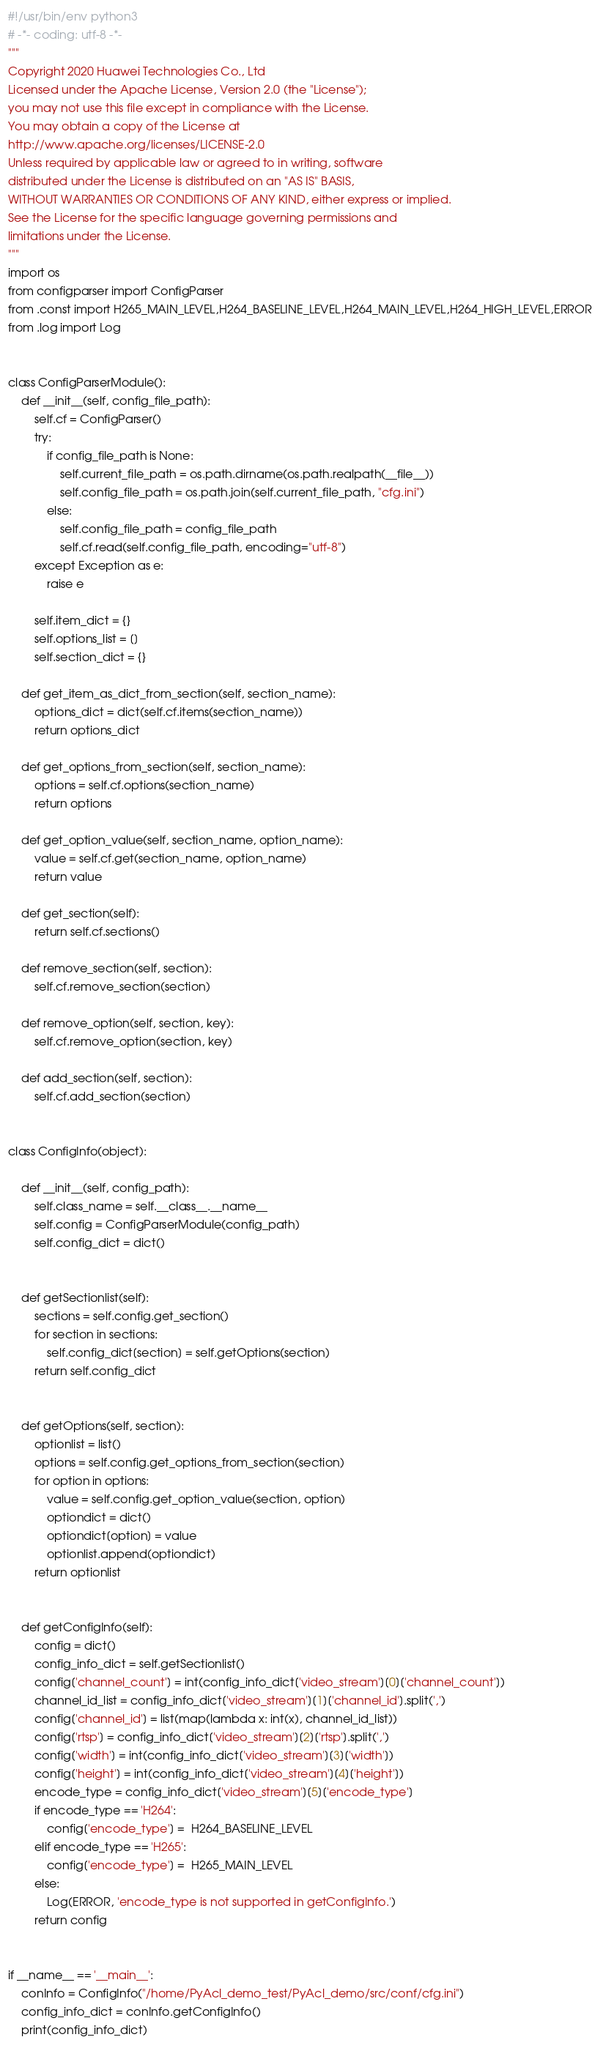<code> <loc_0><loc_0><loc_500><loc_500><_Python_>#!/usr/bin/env python3
# -*- coding: utf-8 -*-
"""
Copyright 2020 Huawei Technologies Co., Ltd
Licensed under the Apache License, Version 2.0 (the "License");
you may not use this file except in compliance with the License.
You may obtain a copy of the License at
http://www.apache.org/licenses/LICENSE-2.0
Unless required by applicable law or agreed to in writing, software
distributed under the License is distributed on an "AS IS" BASIS,
WITHOUT WARRANTIES OR CONDITIONS OF ANY KIND, either express or implied.
See the License for the specific language governing permissions and
limitations under the License.
"""
import os
from configparser import ConfigParser
from .const import H265_MAIN_LEVEL,H264_BASELINE_LEVEL,H264_MAIN_LEVEL,H264_HIGH_LEVEL,ERROR 
from .log import Log


class ConfigParserModule():
    def __init__(self, config_file_path):
        self.cf = ConfigParser()
        try:
            if config_file_path is None:
                self.current_file_path = os.path.dirname(os.path.realpath(__file__))
                self.config_file_path = os.path.join(self.current_file_path, "cfg.ini")
            else:
                self.config_file_path = config_file_path
                self.cf.read(self.config_file_path, encoding="utf-8")
        except Exception as e:
            raise e

        self.item_dict = {}
        self.options_list = []
        self.section_dict = {}

    def get_item_as_dict_from_section(self, section_name):
        options_dict = dict(self.cf.items(section_name))
        return options_dict

    def get_options_from_section(self, section_name):
        options = self.cf.options(section_name)
        return options

    def get_option_value(self, section_name, option_name):
        value = self.cf.get(section_name, option_name)
        return value

    def get_section(self):
        return self.cf.sections()

    def remove_section(self, section):
        self.cf.remove_section(section)

    def remove_option(self, section, key):
        self.cf.remove_option(section, key)

    def add_section(self, section):
        self.cf.add_section(section)


class ConfigInfo(object):
    
    def __init__(self, config_path):
        self.class_name = self.__class__.__name__
        self.config = ConfigParserModule(config_path)
        self.config_dict = dict()


    def getSectionlist(self):
        sections = self.config.get_section()
        for section in sections:
            self.config_dict[section] = self.getOptions(section)
        return self.config_dict


    def getOptions(self, section):
        optionlist = list()
        options = self.config.get_options_from_section(section)
        for option in options:
            value = self.config.get_option_value(section, option)
            optiondict = dict()
            optiondict[option] = value
            optionlist.append(optiondict)
        return optionlist


    def getConfigInfo(self):
        config = dict()
        config_info_dict = self.getSectionlist()
        config['channel_count'] = int(config_info_dict['video_stream'][0]['channel_count'])
        channel_id_list = config_info_dict['video_stream'][1]['channel_id'].split(',')
        config['channel_id'] = list(map(lambda x: int(x), channel_id_list))
        config['rtsp'] = config_info_dict['video_stream'][2]['rtsp'].split(',')
        config['width'] = int(config_info_dict['video_stream'][3]['width'])
        config['height'] = int(config_info_dict['video_stream'][4]['height'])
        encode_type = config_info_dict['video_stream'][5]['encode_type']
        if encode_type == 'H264':
            config['encode_type'] =  H264_BASELINE_LEVEL
        elif encode_type == 'H265':
            config['encode_type'] =  H265_MAIN_LEVEL
        else:
            Log(ERROR, 'encode_type is not supported in getConfigInfo.')
        return config


if __name__ == '__main__':
    conInfo = ConfigInfo("/home/PyAcl_demo_test/PyAcl_demo/src/conf/cfg.ini")
    config_info_dict = conInfo.getConfigInfo()
    print(config_info_dict) 
</code> 